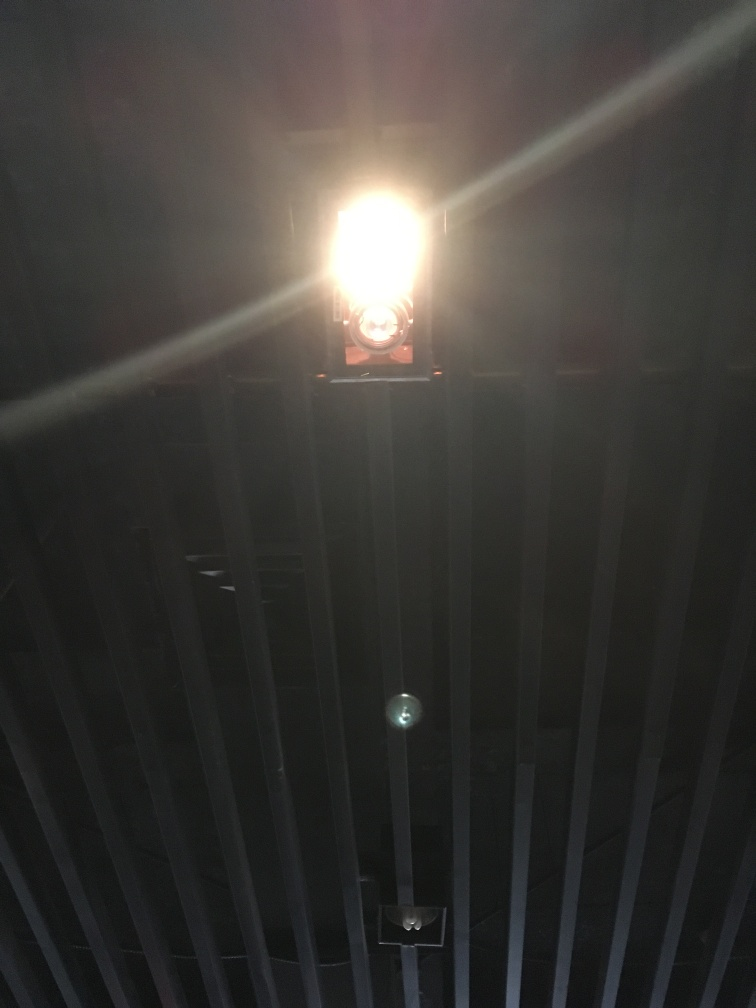Can you describe the light source in the image and speculate on its purpose in this setting? The light source appears to be artificial, likely a bulb situated behind a diffusing cover. Its intense brightness suggests it might be used for illumination in a space where visibility is crucial, or it could serve a symbolic purpose — perhaps in a theatrical setting to create a dramatic effect, or to guide attention to a particular spot, indicating significance. 